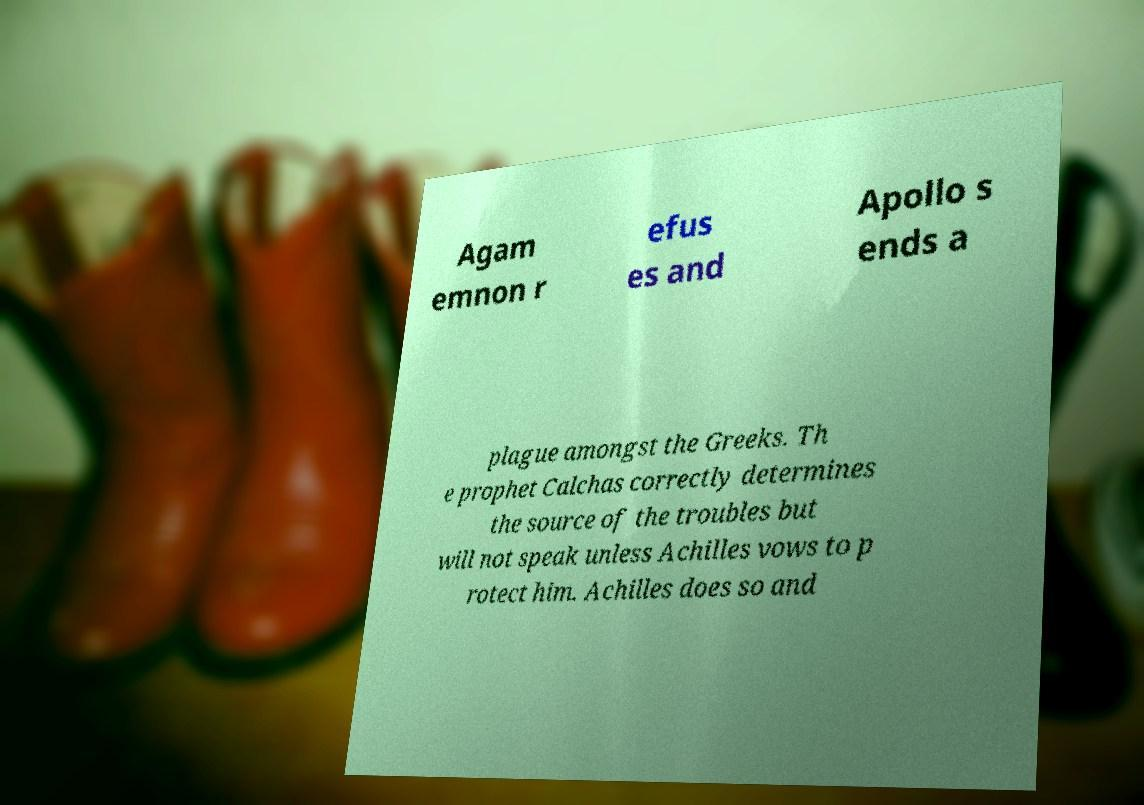Please identify and transcribe the text found in this image. Agam emnon r efus es and Apollo s ends a plague amongst the Greeks. Th e prophet Calchas correctly determines the source of the troubles but will not speak unless Achilles vows to p rotect him. Achilles does so and 